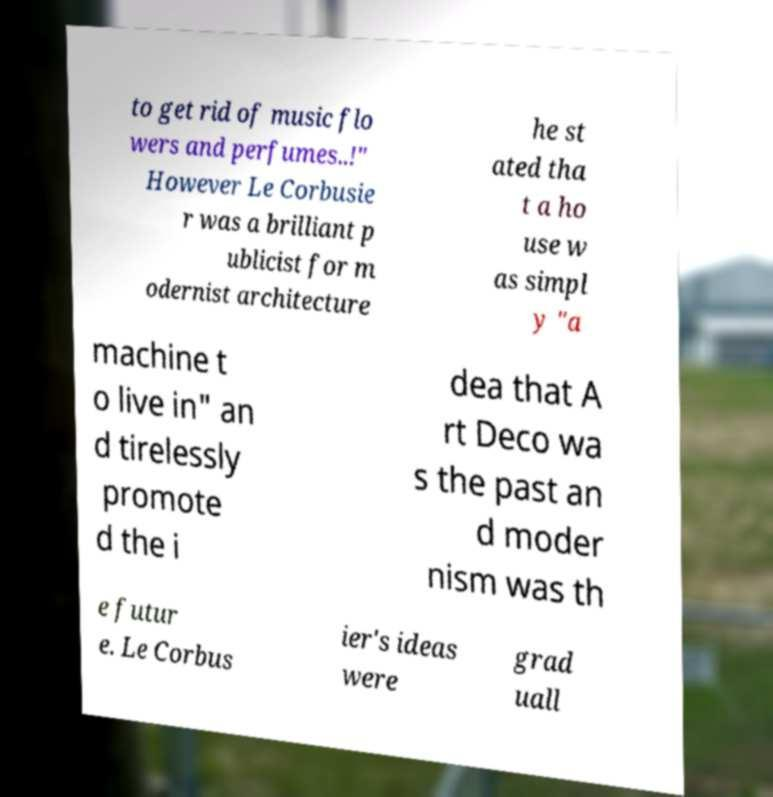Could you assist in decoding the text presented in this image and type it out clearly? to get rid of music flo wers and perfumes..!" However Le Corbusie r was a brilliant p ublicist for m odernist architecture he st ated tha t a ho use w as simpl y "a machine t o live in" an d tirelessly promote d the i dea that A rt Deco wa s the past an d moder nism was th e futur e. Le Corbus ier's ideas were grad uall 